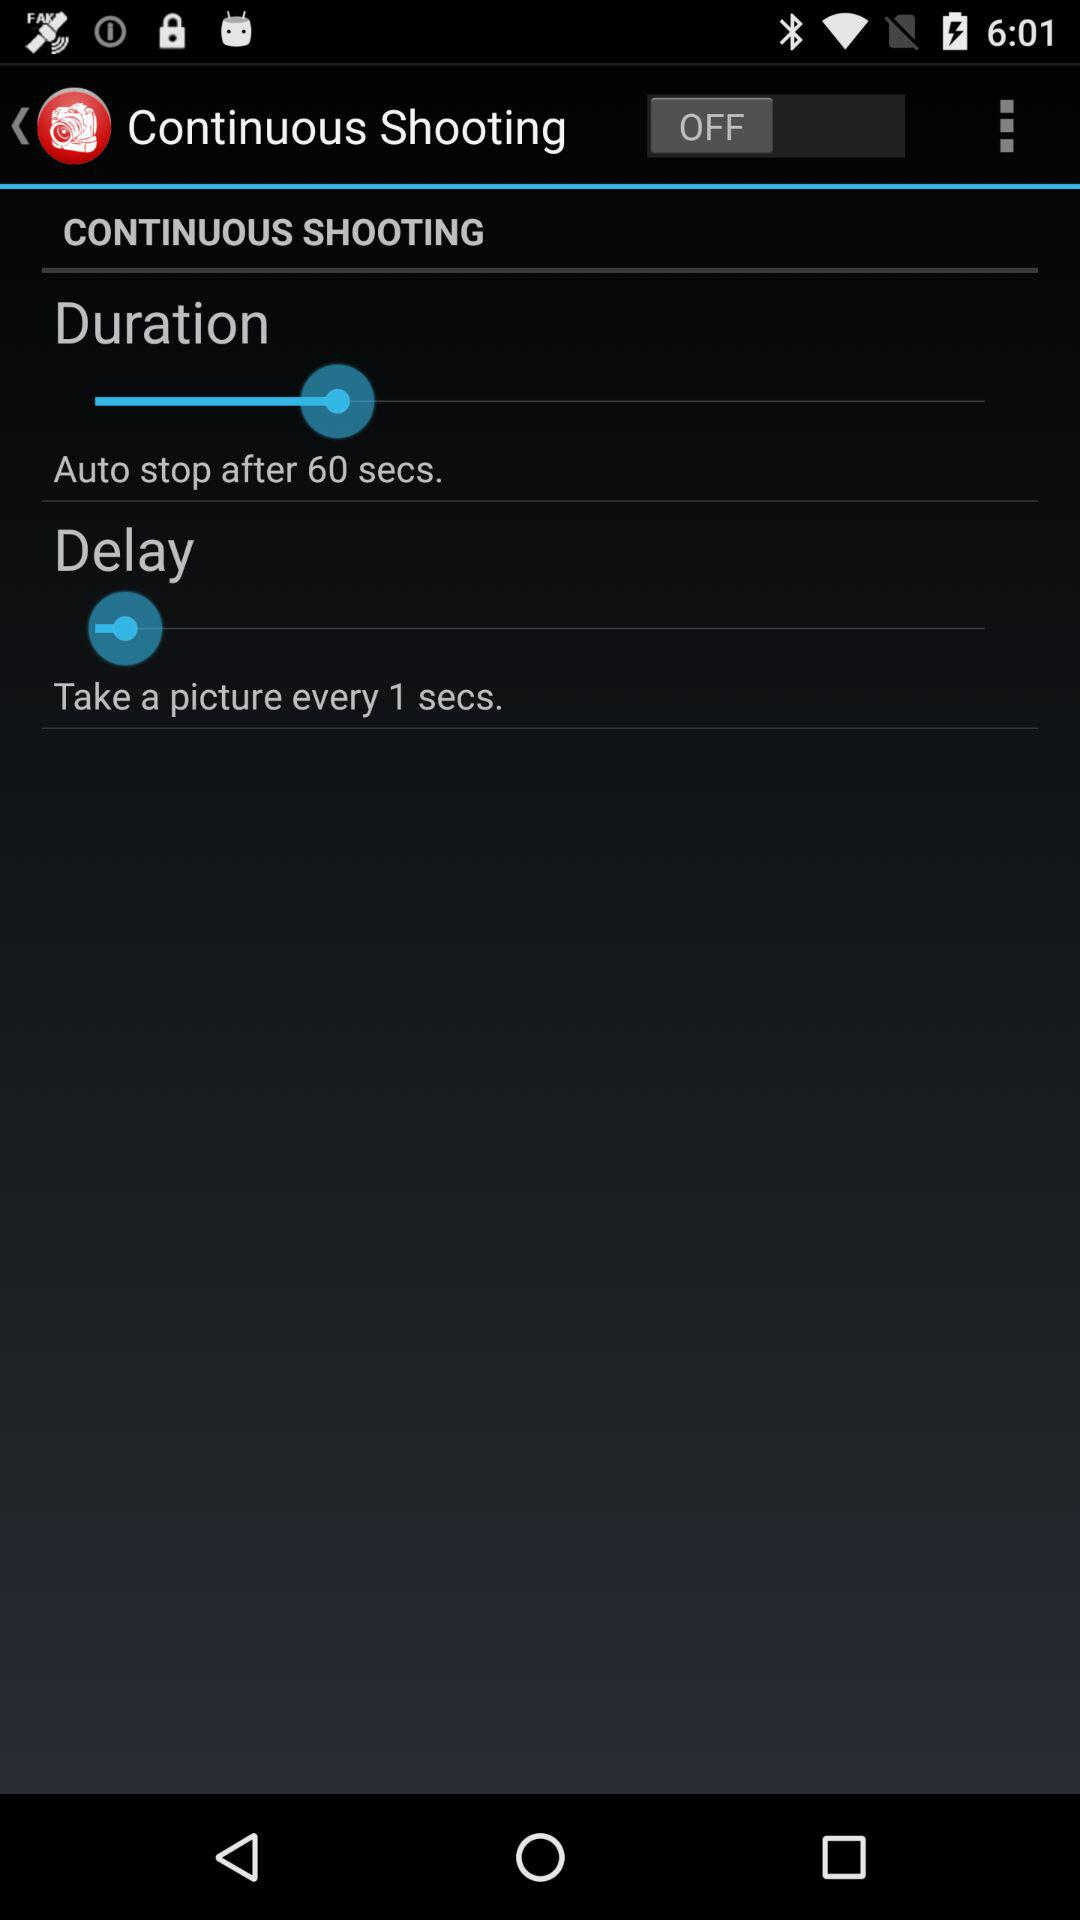How many seconds does the continuous shooting mode last?
Answer the question using a single word or phrase. 60 